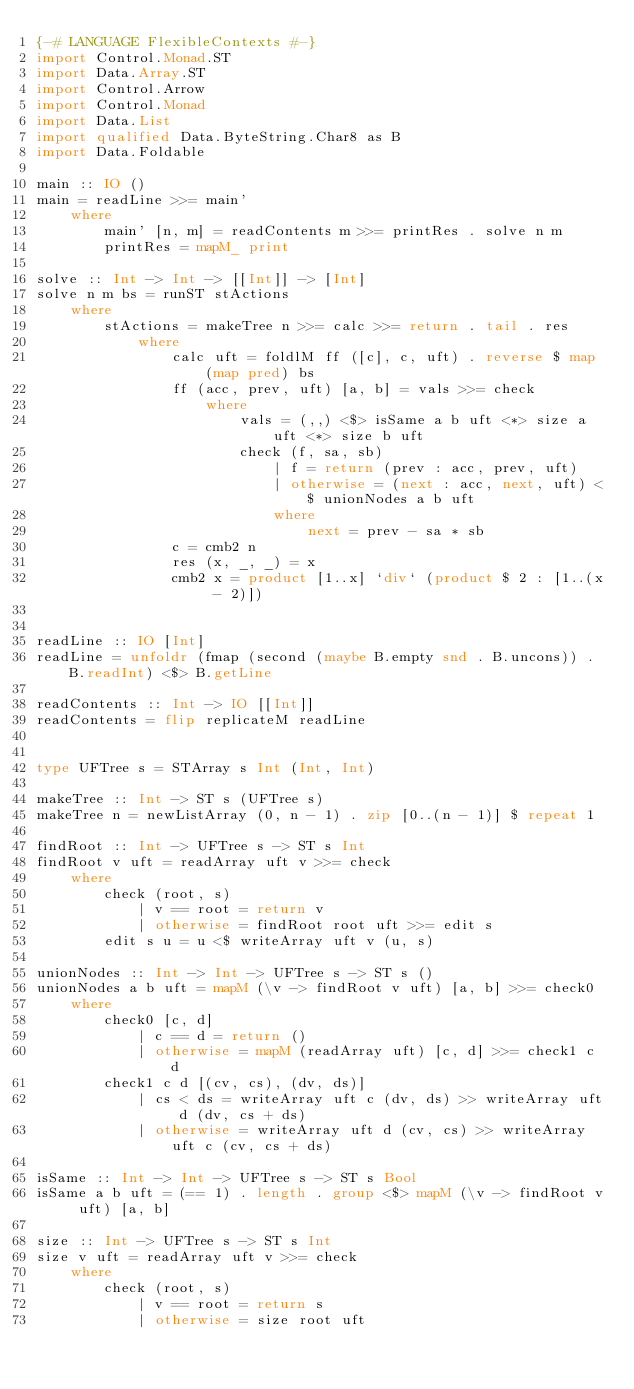Convert code to text. <code><loc_0><loc_0><loc_500><loc_500><_Haskell_>{-# LANGUAGE FlexibleContexts #-}
import Control.Monad.ST
import Data.Array.ST
import Control.Arrow
import Control.Monad
import Data.List
import qualified Data.ByteString.Char8 as B
import Data.Foldable

main :: IO ()
main = readLine >>= main'
    where
        main' [n, m] = readContents m >>= printRes . solve n m
        printRes = mapM_ print 

solve :: Int -> Int -> [[Int]] -> [Int]
solve n m bs = runST stActions
    where
        stActions = makeTree n >>= calc >>= return . tail . res
            where
                calc uft = foldlM ff ([c], c, uft) . reverse $ map (map pred) bs
                ff (acc, prev, uft) [a, b] = vals >>= check
                    where
                        vals = (,,) <$> isSame a b uft <*> size a uft <*> size b uft
                        check (f, sa, sb)
                            | f = return (prev : acc, prev, uft)
                            | otherwise = (next : acc, next, uft) <$ unionNodes a b uft
                            where
                                next = prev - sa * sb
                c = cmb2 n
                res (x, _, _) = x
                cmb2 x = product [1..x] `div` (product $ 2 : [1..(x - 2)])


readLine :: IO [Int]
readLine = unfoldr (fmap (second (maybe B.empty snd . B.uncons)) . B.readInt) <$> B.getLine

readContents :: Int -> IO [[Int]]
readContents = flip replicateM readLine


type UFTree s = STArray s Int (Int, Int)

makeTree :: Int -> ST s (UFTree s)
makeTree n = newListArray (0, n - 1) . zip [0..(n - 1)] $ repeat 1

findRoot :: Int -> UFTree s -> ST s Int
findRoot v uft = readArray uft v >>= check 
    where
        check (root, s)
            | v == root = return v
            | otherwise = findRoot root uft >>= edit s
        edit s u = u <$ writeArray uft v (u, s)
            
unionNodes :: Int -> Int -> UFTree s -> ST s ()
unionNodes a b uft = mapM (\v -> findRoot v uft) [a, b] >>= check0
    where
        check0 [c, d]
            | c == d = return ()
            | otherwise = mapM (readArray uft) [c, d] >>= check1 c d
        check1 c d [(cv, cs), (dv, ds)]
            | cs < ds = writeArray uft c (dv, ds) >> writeArray uft d (dv, cs + ds)
            | otherwise = writeArray uft d (cv, cs) >> writeArray uft c (cv, cs + ds)

isSame :: Int -> Int -> UFTree s -> ST s Bool
isSame a b uft = (== 1) . length . group <$> mapM (\v -> findRoot v uft) [a, b]

size :: Int -> UFTree s -> ST s Int 
size v uft = readArray uft v >>= check
    where
        check (root, s)
            | v == root = return s
            | otherwise = size root uft</code> 